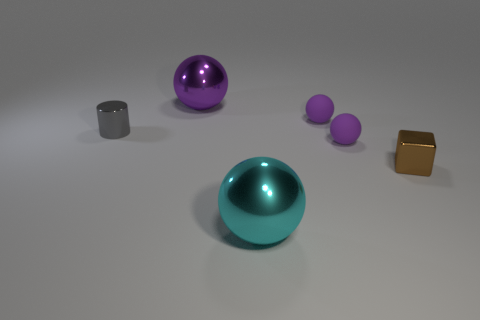What can you tell me about the texture of the objects in the image? The objects in the image have a variety of textures. The cyan and purple spheres have a smooth and reflective texture, giving them a glossy appearance. The gray cylindrical object has a matte finish, suggesting a rougher texture like concrete or unpolished metal. The gold cube also appears to have a smooth, reflective surface, indicating a metallic texture. 